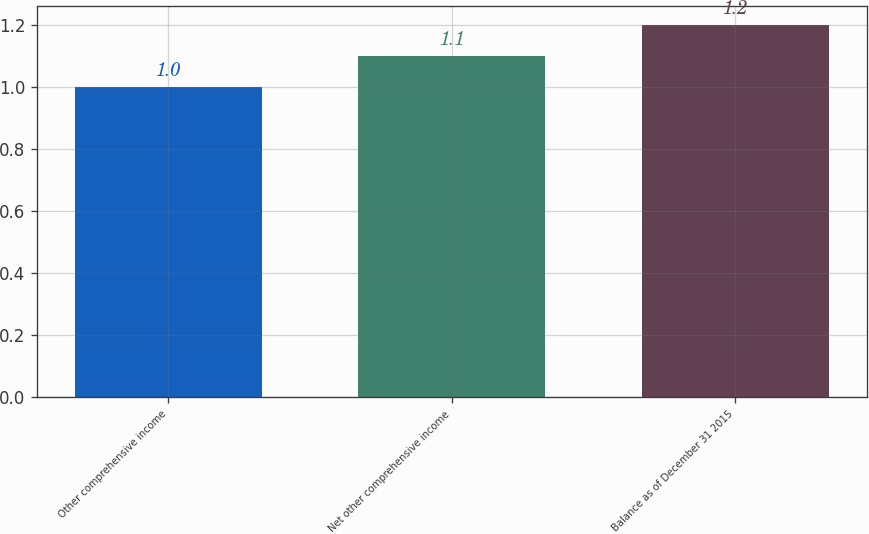Convert chart. <chart><loc_0><loc_0><loc_500><loc_500><bar_chart><fcel>Other comprehensive income<fcel>Net other comprehensive income<fcel>Balance as of December 31 2015<nl><fcel>1<fcel>1.1<fcel>1.2<nl></chart> 